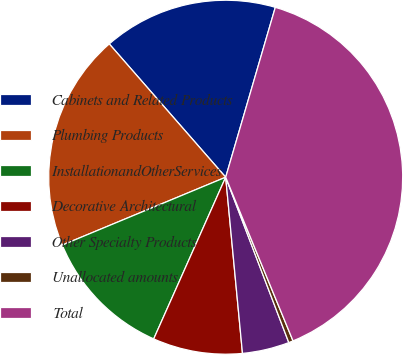Convert chart to OTSL. <chart><loc_0><loc_0><loc_500><loc_500><pie_chart><fcel>Cabinets and Related Products<fcel>Plumbing Products<fcel>InstallationandOtherServices<fcel>Decorative Architectural<fcel>Other Specialty Products<fcel>Unallocated amounts<fcel>Total<nl><fcel>15.95%<fcel>19.84%<fcel>12.07%<fcel>8.18%<fcel>4.29%<fcel>0.41%<fcel>39.27%<nl></chart> 